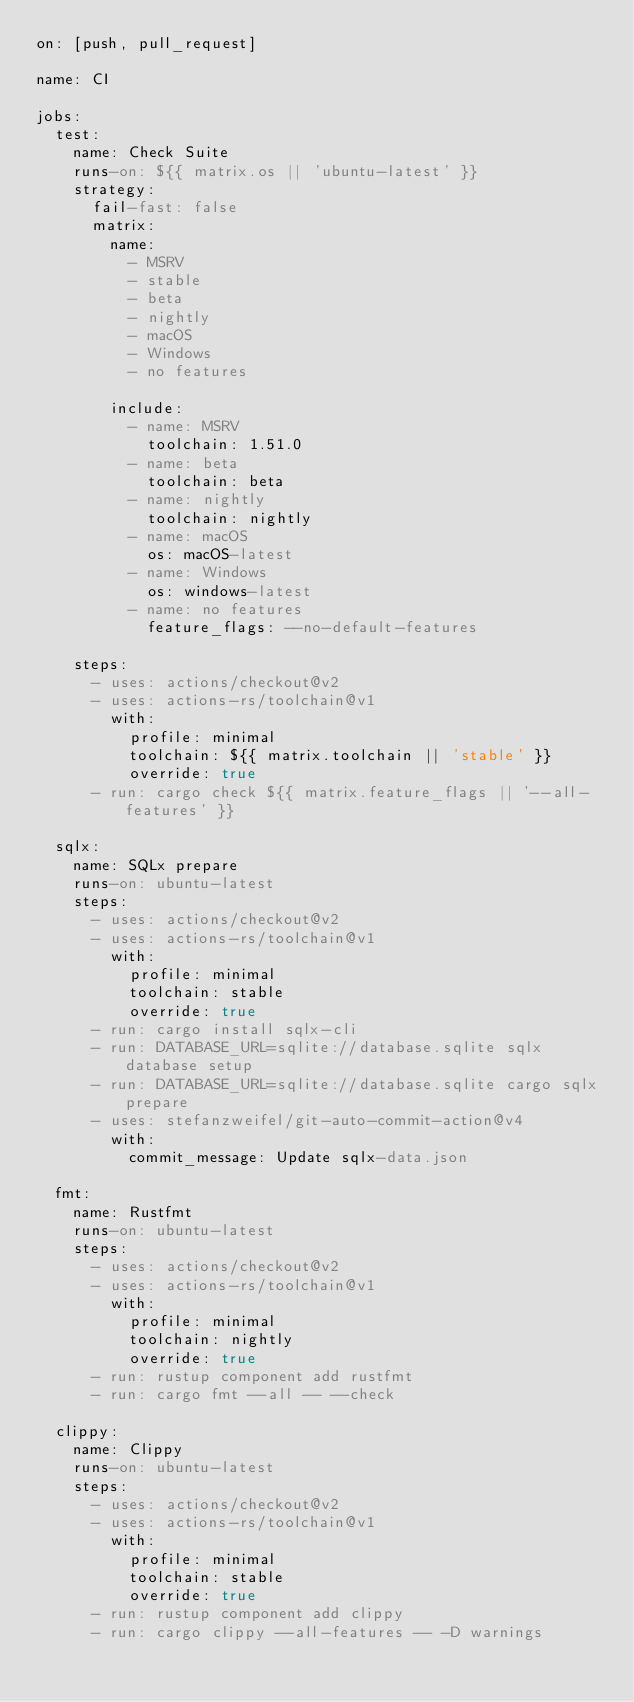<code> <loc_0><loc_0><loc_500><loc_500><_YAML_>on: [push, pull_request]

name: CI

jobs:
  test:
    name: Check Suite
    runs-on: ${{ matrix.os || 'ubuntu-latest' }}
    strategy:
      fail-fast: false
      matrix:
        name:
          - MSRV
          - stable
          - beta
          - nightly
          - macOS
          - Windows
          - no features

        include:
          - name: MSRV
            toolchain: 1.51.0
          - name: beta
            toolchain: beta
          - name: nightly
            toolchain: nightly
          - name: macOS
            os: macOS-latest
          - name: Windows
            os: windows-latest
          - name: no features
            feature_flags: --no-default-features

    steps:
      - uses: actions/checkout@v2
      - uses: actions-rs/toolchain@v1
        with:
          profile: minimal
          toolchain: ${{ matrix.toolchain || 'stable' }}
          override: true
      - run: cargo check ${{ matrix.feature_flags || '--all-features' }}

  sqlx:
    name: SQLx prepare
    runs-on: ubuntu-latest
    steps:
      - uses: actions/checkout@v2
      - uses: actions-rs/toolchain@v1
        with:
          profile: minimal
          toolchain: stable
          override: true
      - run: cargo install sqlx-cli
      - run: DATABASE_URL=sqlite://database.sqlite sqlx database setup
      - run: DATABASE_URL=sqlite://database.sqlite cargo sqlx prepare
      - uses: stefanzweifel/git-auto-commit-action@v4
        with:
          commit_message: Update sqlx-data.json

  fmt:
    name: Rustfmt
    runs-on: ubuntu-latest
    steps:
      - uses: actions/checkout@v2
      - uses: actions-rs/toolchain@v1
        with:
          profile: minimal
          toolchain: nightly
          override: true
      - run: rustup component add rustfmt
      - run: cargo fmt --all -- --check

  clippy:
    name: Clippy
    runs-on: ubuntu-latest
    steps:
      - uses: actions/checkout@v2
      - uses: actions-rs/toolchain@v1
        with:
          profile: minimal
          toolchain: stable
          override: true
      - run: rustup component add clippy
      - run: cargo clippy --all-features -- -D warnings
</code> 